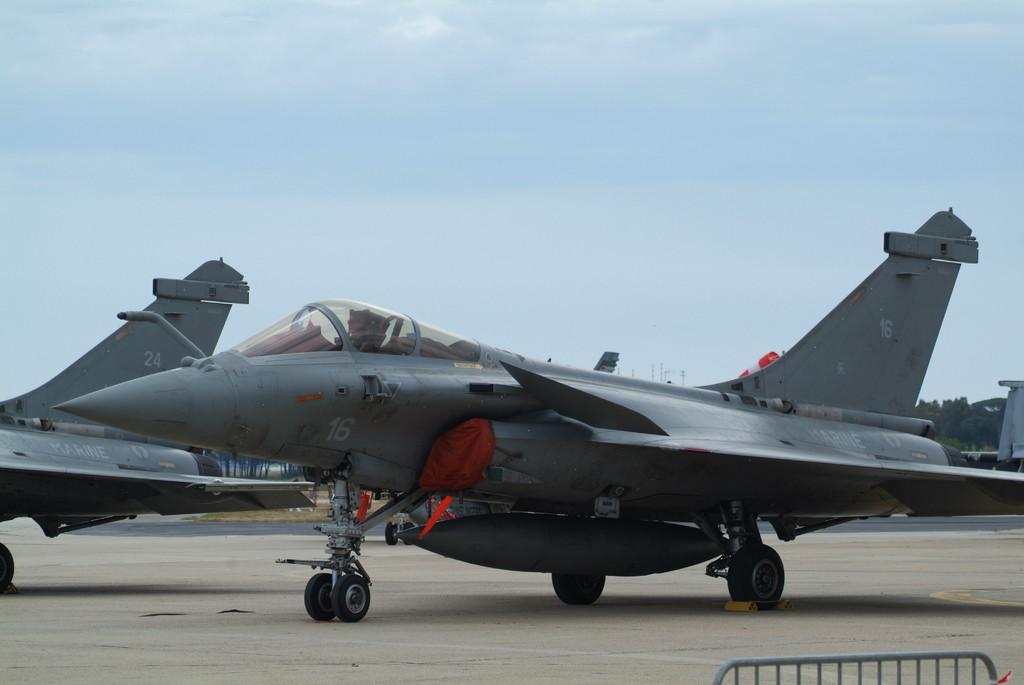What unusual objects can be seen on the road in the image? There are aeroplanes on the road in the image. What type of natural environment is visible in the background of the image? There are trees in the background of the image. What part of the natural environment is visible in the image? The sky is visible in the background of the image. What song is being played by the toothbrush in the image? There is no toothbrush present in the image, and therefore no song being played. 